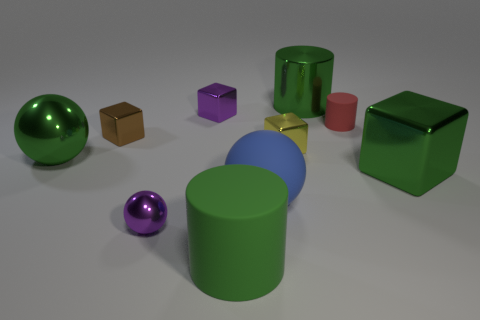Does the blue object have the same shape as the tiny red matte thing?
Your response must be concise. No. There is a metal ball that is behind the big block; how big is it?
Offer a terse response. Large. There is a purple shiny cube; is its size the same as the purple metal object in front of the tiny matte cylinder?
Your answer should be very brief. Yes. Are there fewer large balls in front of the big green metal cube than purple objects?
Provide a short and direct response. Yes. What is the material of the brown object that is the same shape as the yellow object?
Your answer should be very brief. Metal. The shiny thing that is on the left side of the big green matte object and behind the tiny matte thing has what shape?
Ensure brevity in your answer.  Cube. There is a tiny purple thing that is the same material as the purple ball; what is its shape?
Keep it short and to the point. Cube. There is a purple thing that is behind the blue object; what material is it?
Ensure brevity in your answer.  Metal. There is a ball right of the large matte cylinder; is it the same size as the purple thing in front of the large block?
Keep it short and to the point. No. What is the color of the large shiny cube?
Your answer should be compact. Green. 